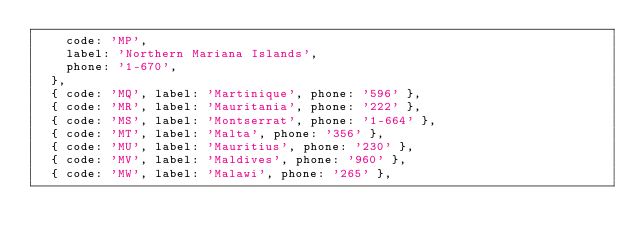Convert code to text. <code><loc_0><loc_0><loc_500><loc_500><_TypeScript_>    code: 'MP',
    label: 'Northern Mariana Islands',
    phone: '1-670',
  },
  { code: 'MQ', label: 'Martinique', phone: '596' },
  { code: 'MR', label: 'Mauritania', phone: '222' },
  { code: 'MS', label: 'Montserrat', phone: '1-664' },
  { code: 'MT', label: 'Malta', phone: '356' },
  { code: 'MU', label: 'Mauritius', phone: '230' },
  { code: 'MV', label: 'Maldives', phone: '960' },
  { code: 'MW', label: 'Malawi', phone: '265' },</code> 